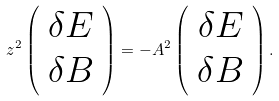Convert formula to latex. <formula><loc_0><loc_0><loc_500><loc_500>z ^ { 2 } \left ( \begin{array} { c c } \delta E \\ \delta B \end{array} \right ) = - A ^ { 2 } \left ( \begin{array} { c c } \delta E \\ \delta B \end{array} \right ) .</formula> 